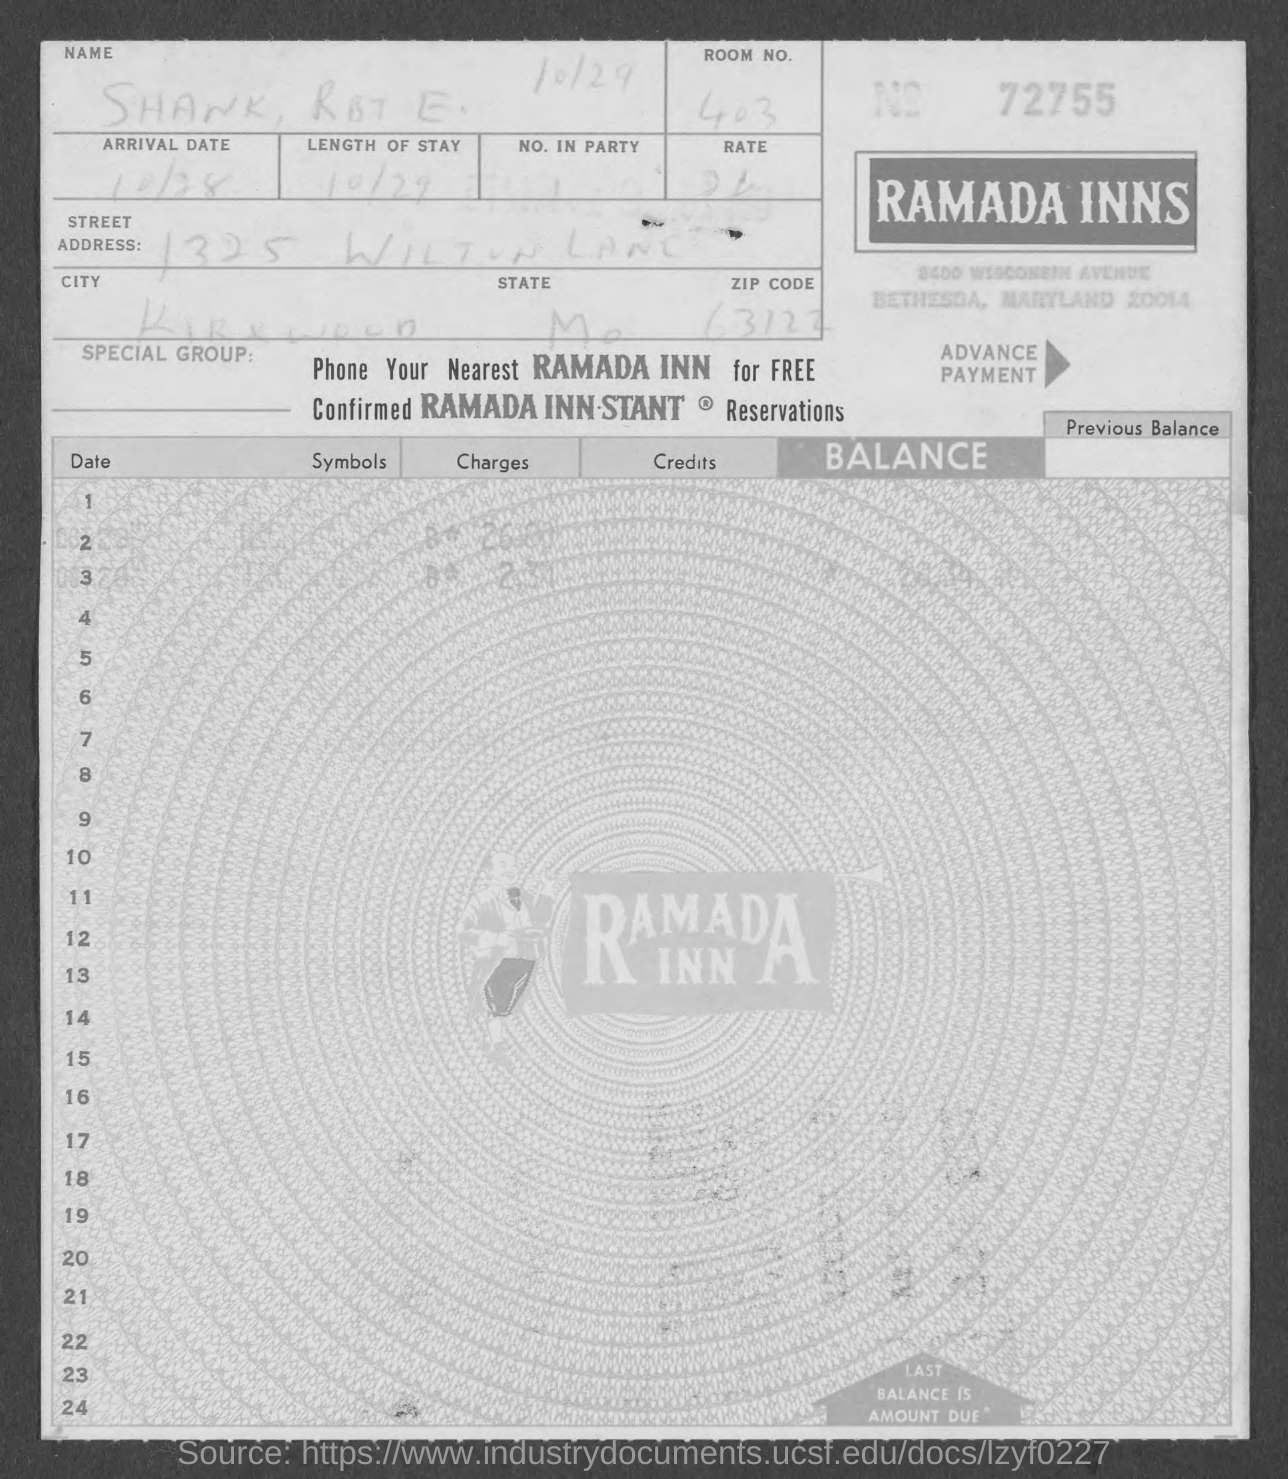What is the invoice no.?
Ensure brevity in your answer.  72755. 